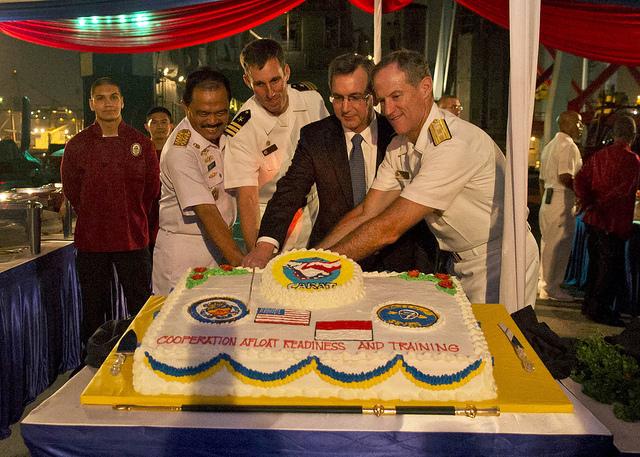Are these people military?
Answer briefly. Yes. Are the men happy?
Keep it brief. Yes. Are they cutting into a pie?
Quick response, please. No. 